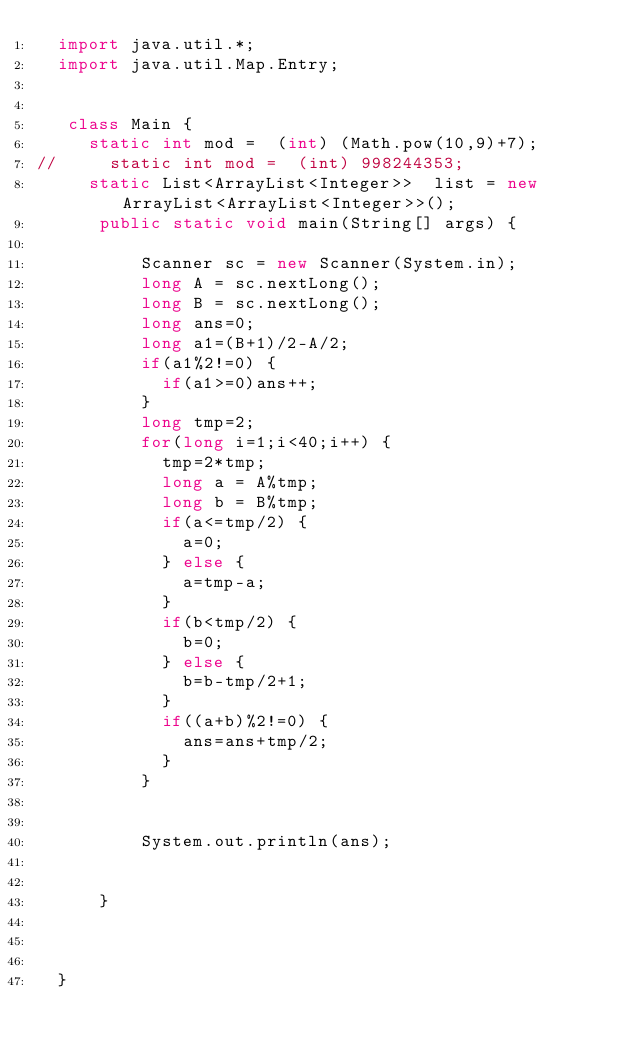Convert code to text. <code><loc_0><loc_0><loc_500><loc_500><_Java_>	import java.util.*;
	import java.util.Map.Entry;
	 
	 
	 class Main {
		 static int mod =  (int) (Math.pow(10,9)+7);
//		 static int mod =  (int) 998244353;
		 static List<ArrayList<Integer>>  list = new ArrayList<ArrayList<Integer>>();
	    public static void main(String[] args) {
	    	
	        Scanner sc = new Scanner(System.in);
	        long A = sc.nextLong();
	        long B = sc.nextLong();
	        long ans=0;
	        long a1=(B+1)/2-A/2;
	        if(a1%2!=0) {
	        	if(a1>=0)ans++;
	        }
	        long tmp=2;
	        for(long i=1;i<40;i++) {
	        	tmp=2*tmp;
	        	long a = A%tmp;
	        	long b = B%tmp;
	        	if(a<=tmp/2) {
	        		a=0;
	        	} else {
	        		a=tmp-a;
	        	}
	        	if(b<tmp/2) {
	        		b=0;
	        	} else {
	        		b=b-tmp/2+1;
	        	}
	        	if((a+b)%2!=0) {
	        		ans=ans+tmp/2;
	        	}
	        }
	        
	        
	        System.out.println(ans);
	        

	    }
	    
	    

	}</code> 